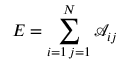<formula> <loc_0><loc_0><loc_500><loc_500>E = \sum _ { \substack { i = 1 \, j = 1 } } ^ { N } \mathcal { A } _ { i j }</formula> 